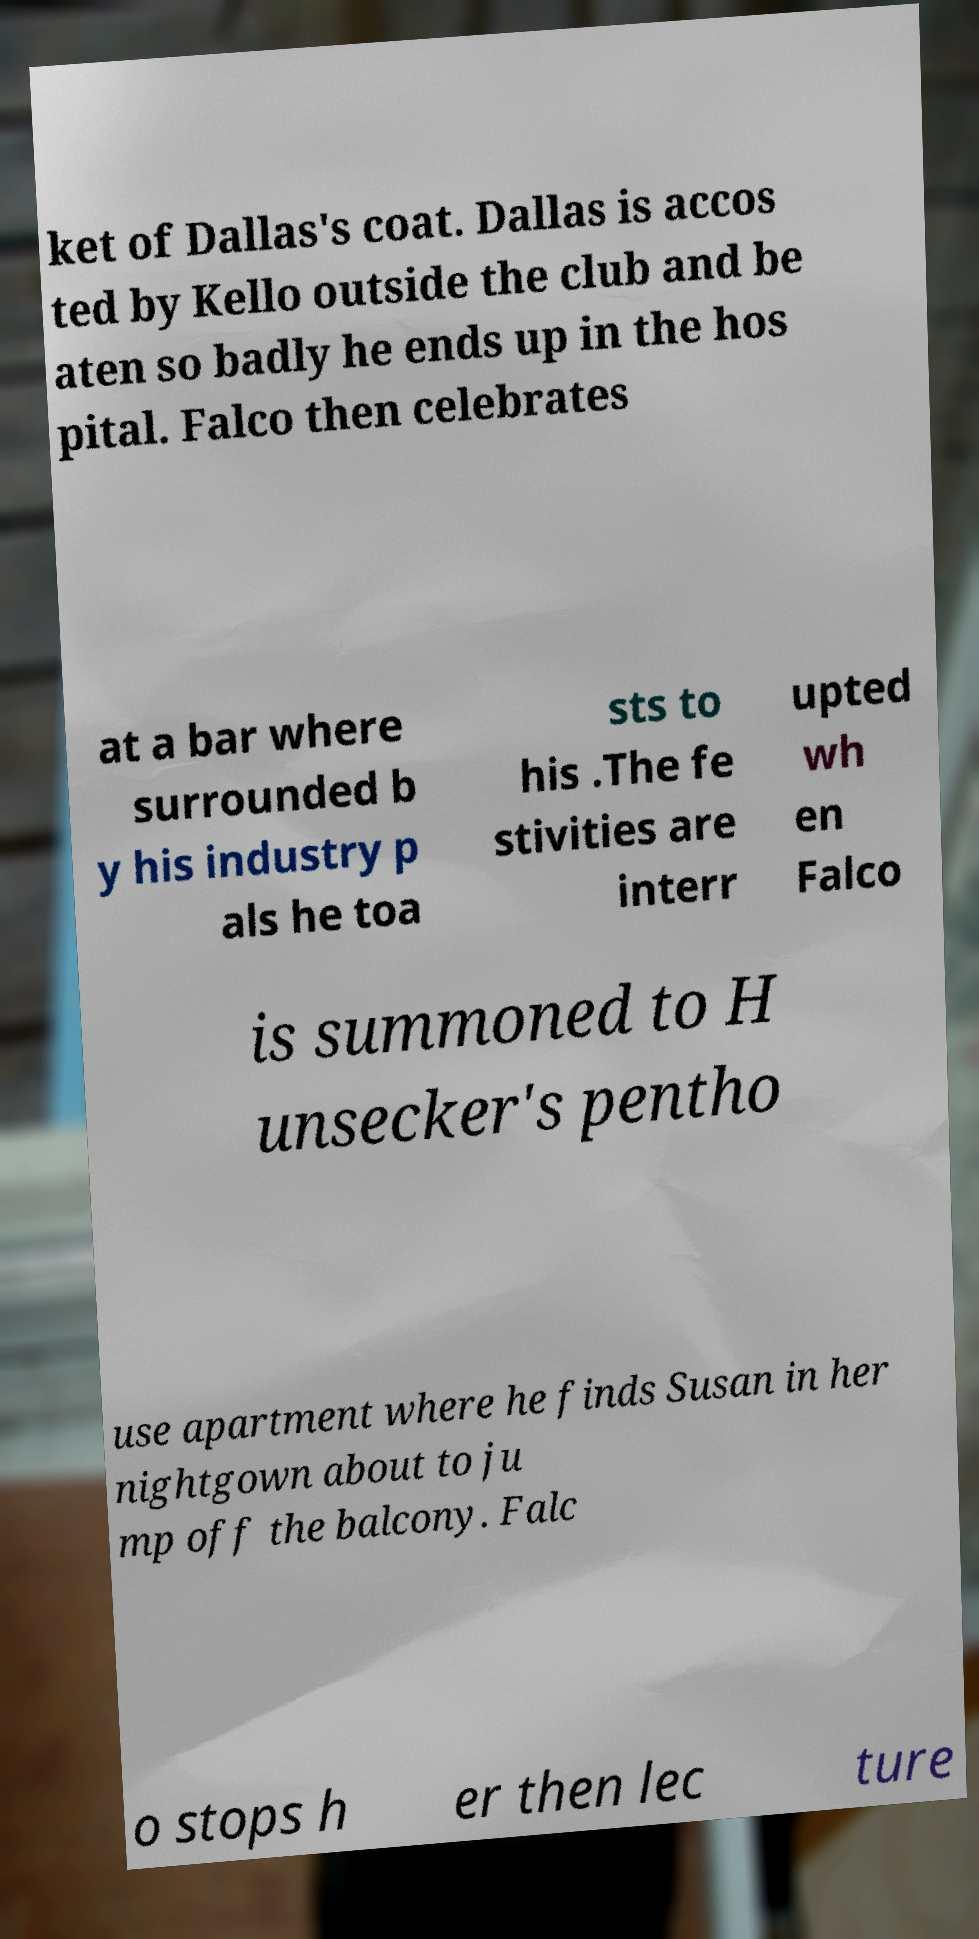There's text embedded in this image that I need extracted. Can you transcribe it verbatim? ket of Dallas's coat. Dallas is accos ted by Kello outside the club and be aten so badly he ends up in the hos pital. Falco then celebrates at a bar where surrounded b y his industry p als he toa sts to his .The fe stivities are interr upted wh en Falco is summoned to H unsecker's pentho use apartment where he finds Susan in her nightgown about to ju mp off the balcony. Falc o stops h er then lec ture 